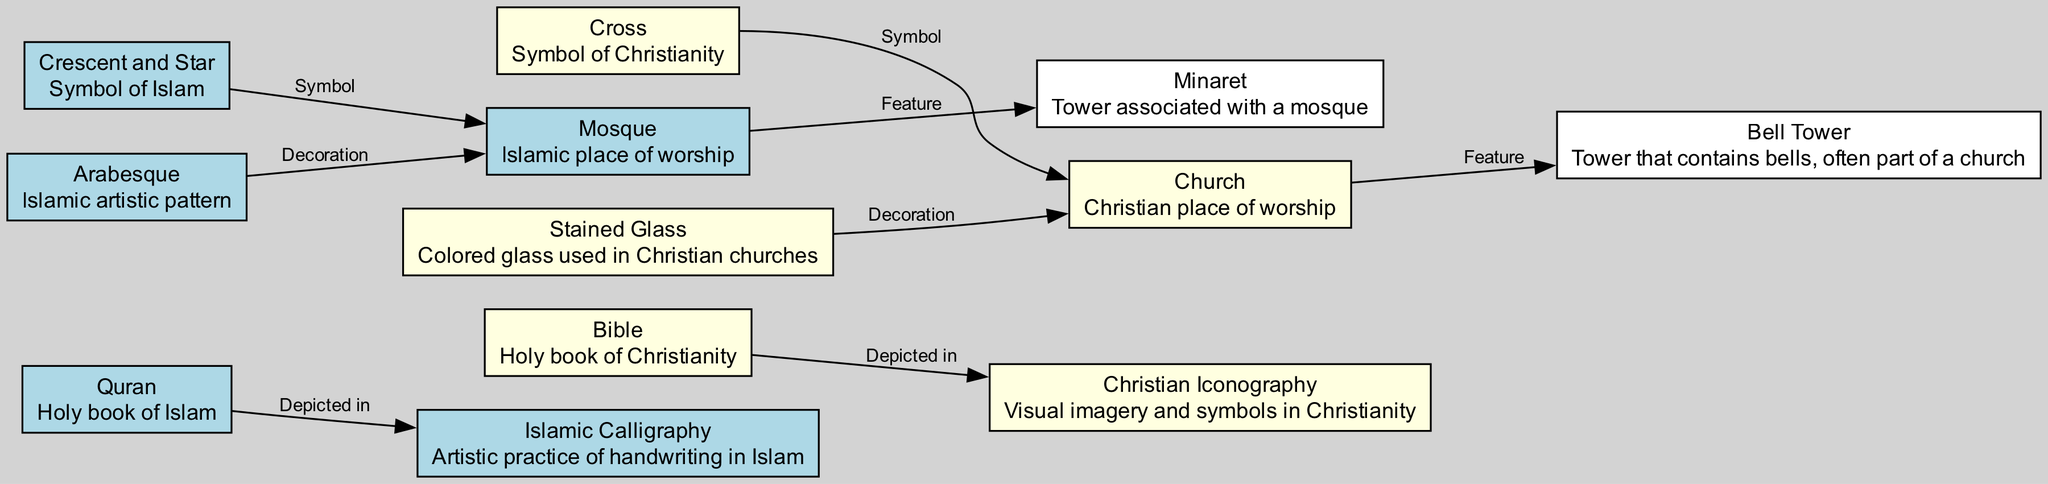What is the holy book of Islam? The diagram specifies that the "Quran" is labeled as the holy book of Islam.
Answer: Quran What architectural feature is associated with mosques? The diagram indicates that the "Minaret" is listed as a distinct architectural feature of mosques.
Answer: Minaret How many primary symbolic representations are depicted for Christianity? The diagram shows one primary symbol, which is the "Cross," for Christianity.
Answer: One What type of artistic practice is associated with the Quran? According to the information provided, "Islamic Calligraphy" is depicted in relation to the Quran as the artistic practice associated with it.
Answer: Islamic Calligraphy Which symbol is commonly found in churches? The diagram identifies the "Cross" as a common symbolic motif found in churches.
Answer: Cross What two elements are shown as decorative features in their respective religious architectures? The diagram displays "Arabesque" used in mosques and "Stained Glass" in churches as decoration in their respective architectures.
Answer: Arabesque and Stained Glass Which item is depicted as a place of worship for Christians? The diagram specifically labels "Church" as the place of worship for Christianity.
Answer: Church What symbol unites the mosque with Islamic culture? The diagram clarifies that the "Crescent and Star" symbol is a common motif associated with mosques, establishing its link to Islamic culture.
Answer: Crescent and Star How do the Quran and Bible visually represent their religious texts? The diagram mentions that the "Quran" is depicted in "Calligraphy" while the "Bible" is depicted in "Iconography," showcasing the visual representation of each text.
Answer: Calligraphy and Iconography 